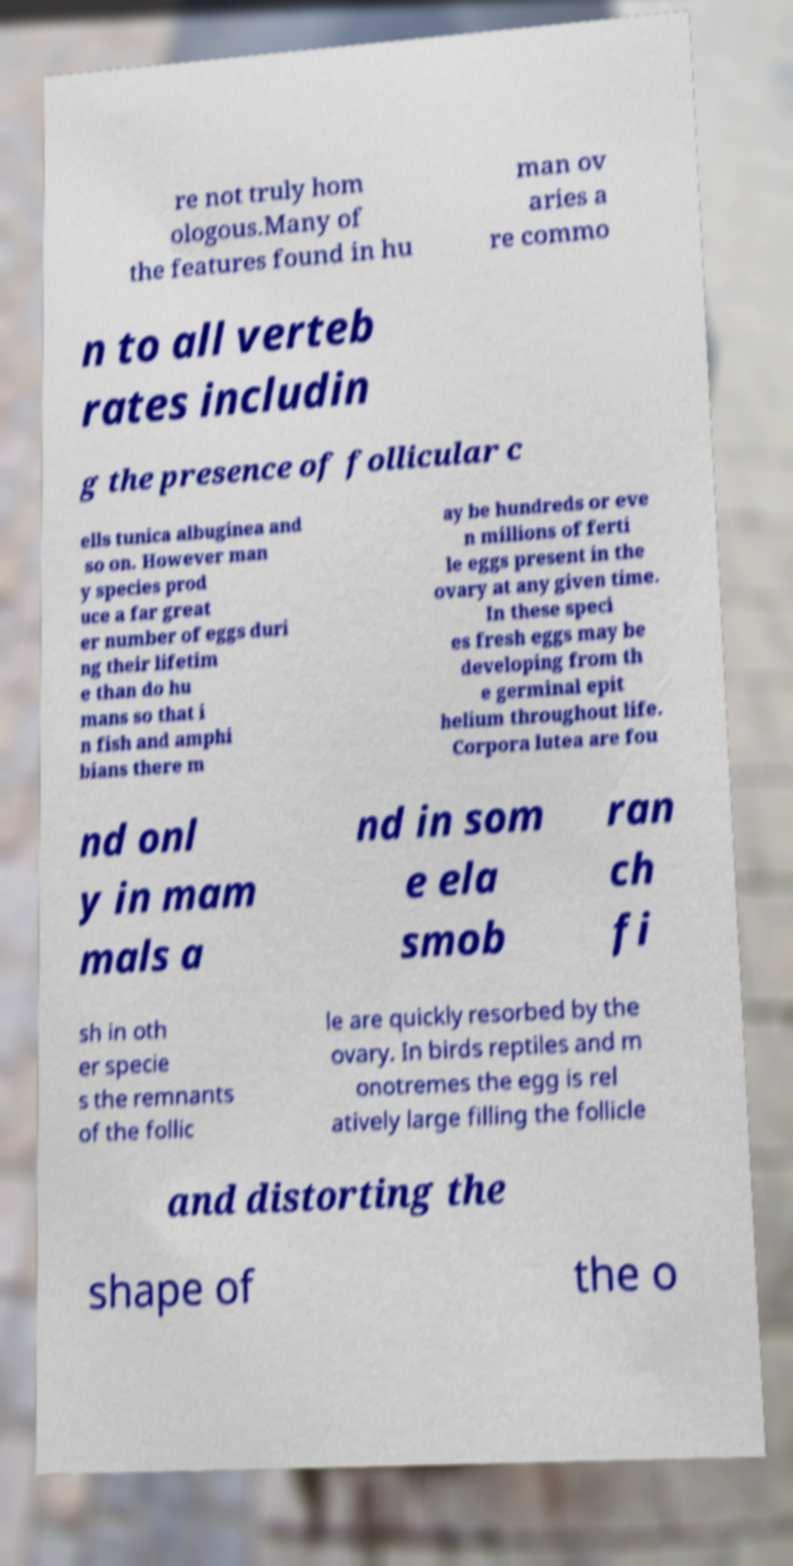Please identify and transcribe the text found in this image. re not truly hom ologous.Many of the features found in hu man ov aries a re commo n to all verteb rates includin g the presence of follicular c ells tunica albuginea and so on. However man y species prod uce a far great er number of eggs duri ng their lifetim e than do hu mans so that i n fish and amphi bians there m ay be hundreds or eve n millions of ferti le eggs present in the ovary at any given time. In these speci es fresh eggs may be developing from th e germinal epit helium throughout life. Corpora lutea are fou nd onl y in mam mals a nd in som e ela smob ran ch fi sh in oth er specie s the remnants of the follic le are quickly resorbed by the ovary. In birds reptiles and m onotremes the egg is rel atively large filling the follicle and distorting the shape of the o 